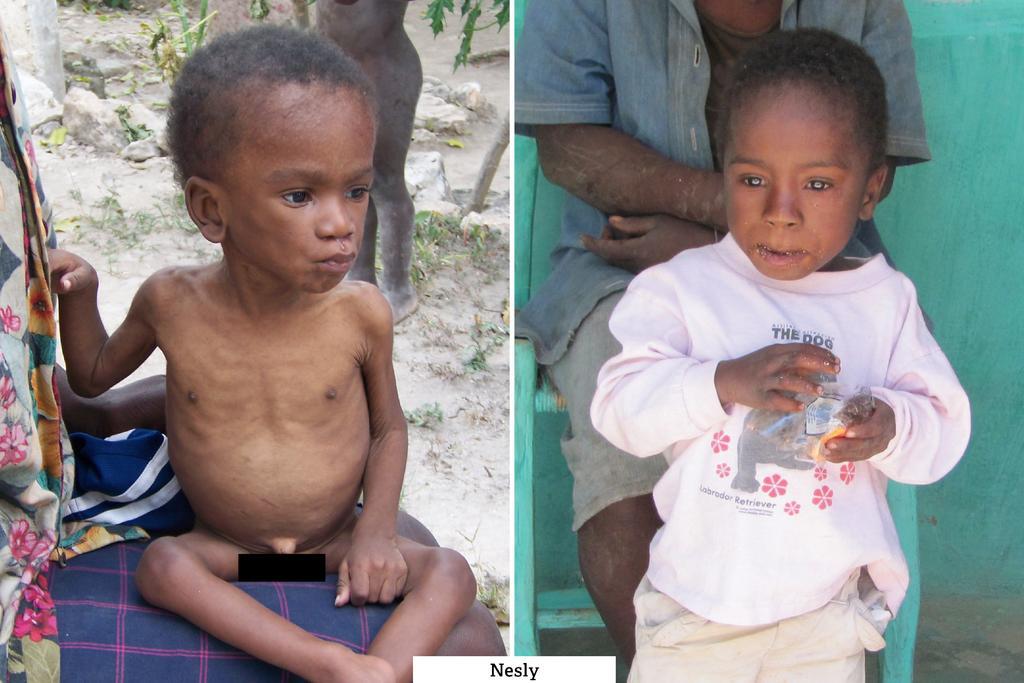Can you describe this image briefly? This image is a collage. In this image there are people and we can see rocks. There are plants and we can see a wall. 